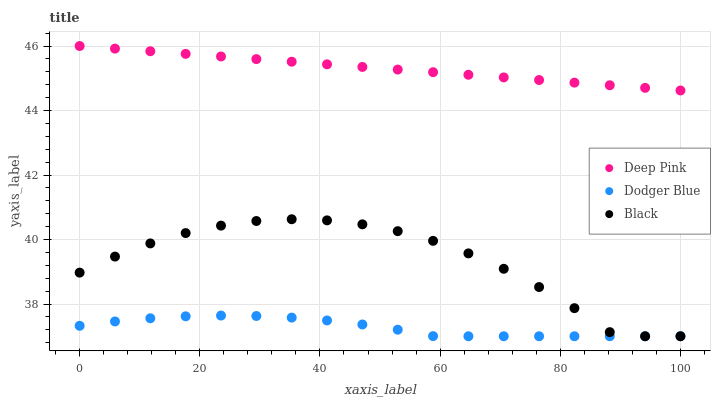Does Dodger Blue have the minimum area under the curve?
Answer yes or no. Yes. Does Deep Pink have the maximum area under the curve?
Answer yes or no. Yes. Does Deep Pink have the minimum area under the curve?
Answer yes or no. No. Does Dodger Blue have the maximum area under the curve?
Answer yes or no. No. Is Deep Pink the smoothest?
Answer yes or no. Yes. Is Black the roughest?
Answer yes or no. Yes. Is Dodger Blue the smoothest?
Answer yes or no. No. Is Dodger Blue the roughest?
Answer yes or no. No. Does Black have the lowest value?
Answer yes or no. Yes. Does Deep Pink have the lowest value?
Answer yes or no. No. Does Deep Pink have the highest value?
Answer yes or no. Yes. Does Dodger Blue have the highest value?
Answer yes or no. No. Is Black less than Deep Pink?
Answer yes or no. Yes. Is Deep Pink greater than Dodger Blue?
Answer yes or no. Yes. Does Dodger Blue intersect Black?
Answer yes or no. Yes. Is Dodger Blue less than Black?
Answer yes or no. No. Is Dodger Blue greater than Black?
Answer yes or no. No. Does Black intersect Deep Pink?
Answer yes or no. No. 